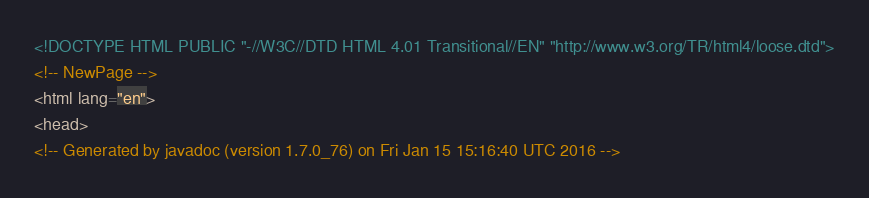Convert code to text. <code><loc_0><loc_0><loc_500><loc_500><_HTML_><!DOCTYPE HTML PUBLIC "-//W3C//DTD HTML 4.01 Transitional//EN" "http://www.w3.org/TR/html4/loose.dtd">
<!-- NewPage -->
<html lang="en">
<head>
<!-- Generated by javadoc (version 1.7.0_76) on Fri Jan 15 15:16:40 UTC 2016 --></code> 